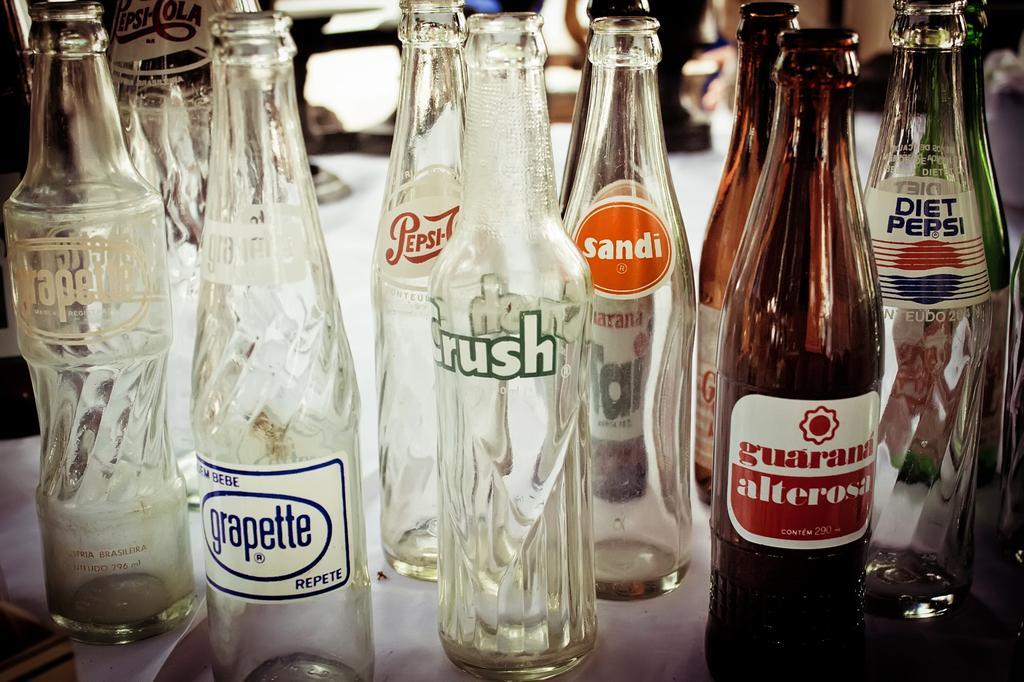Please provide a concise description of this image. There are many bottles on the table. On bottles there are labels. 